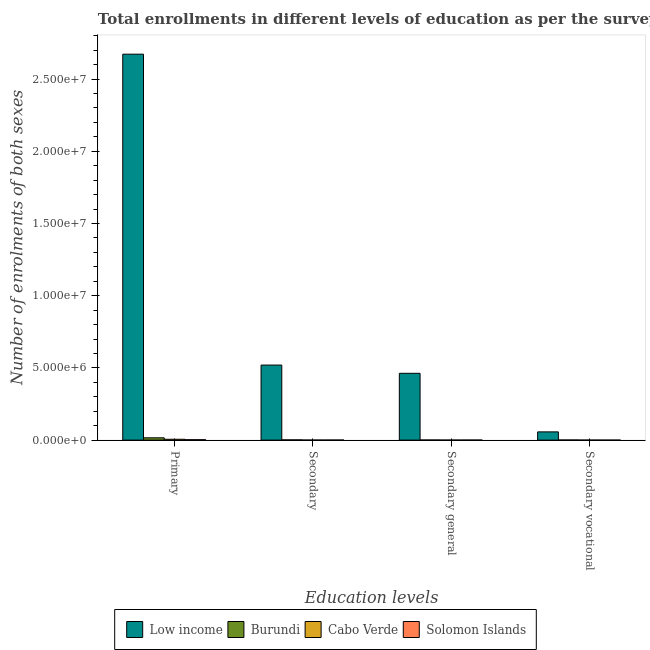Are the number of bars on each tick of the X-axis equal?
Your answer should be compact. Yes. How many bars are there on the 1st tick from the left?
Provide a succinct answer. 4. What is the label of the 3rd group of bars from the left?
Make the answer very short. Secondary general. What is the number of enrolments in primary education in Solomon Islands?
Offer a terse response. 2.89e+04. Across all countries, what is the maximum number of enrolments in secondary general education?
Provide a short and direct response. 4.63e+06. Across all countries, what is the minimum number of enrolments in secondary general education?
Your response must be concise. 2491. In which country was the number of enrolments in secondary general education maximum?
Your answer should be very brief. Low income. In which country was the number of enrolments in primary education minimum?
Provide a short and direct response. Solomon Islands. What is the total number of enrolments in primary education in the graph?
Ensure brevity in your answer.  2.70e+07. What is the difference between the number of enrolments in secondary general education in Burundi and that in Low income?
Offer a terse response. -4.62e+06. What is the difference between the number of enrolments in secondary general education in Solomon Islands and the number of enrolments in primary education in Cabo Verde?
Provide a succinct answer. -5.46e+04. What is the average number of enrolments in secondary education per country?
Your answer should be very brief. 1.30e+06. What is the difference between the number of enrolments in secondary vocational education and number of enrolments in primary education in Cabo Verde?
Ensure brevity in your answer.  -5.75e+04. What is the ratio of the number of enrolments in secondary vocational education in Low income to that in Burundi?
Ensure brevity in your answer.  67.57. Is the number of enrolments in secondary vocational education in Cabo Verde less than that in Burundi?
Offer a very short reply. Yes. Is the difference between the number of enrolments in secondary education in Burundi and Cabo Verde greater than the difference between the number of enrolments in secondary general education in Burundi and Cabo Verde?
Provide a short and direct response. Yes. What is the difference between the highest and the second highest number of enrolments in primary education?
Give a very brief answer. 2.66e+07. What is the difference between the highest and the lowest number of enrolments in secondary general education?
Your answer should be very brief. 4.62e+06. In how many countries, is the number of enrolments in secondary vocational education greater than the average number of enrolments in secondary vocational education taken over all countries?
Your answer should be compact. 1. Is the sum of the number of enrolments in secondary vocational education in Low income and Burundi greater than the maximum number of enrolments in secondary general education across all countries?
Offer a terse response. No. Is it the case that in every country, the sum of the number of enrolments in secondary vocational education and number of enrolments in primary education is greater than the sum of number of enrolments in secondary general education and number of enrolments in secondary education?
Make the answer very short. Yes. What does the 1st bar from the right in Secondary general represents?
Your answer should be compact. Solomon Islands. Is it the case that in every country, the sum of the number of enrolments in primary education and number of enrolments in secondary education is greater than the number of enrolments in secondary general education?
Give a very brief answer. Yes. Are all the bars in the graph horizontal?
Offer a very short reply. No. How many countries are there in the graph?
Ensure brevity in your answer.  4. Are the values on the major ticks of Y-axis written in scientific E-notation?
Make the answer very short. Yes. Does the graph contain any zero values?
Provide a succinct answer. No. Does the graph contain grids?
Provide a succinct answer. No. Where does the legend appear in the graph?
Give a very brief answer. Bottom center. How many legend labels are there?
Offer a terse response. 4. How are the legend labels stacked?
Make the answer very short. Horizontal. What is the title of the graph?
Your answer should be compact. Total enrollments in different levels of education as per the survey of 1980. Does "Cuba" appear as one of the legend labels in the graph?
Ensure brevity in your answer.  No. What is the label or title of the X-axis?
Give a very brief answer. Education levels. What is the label or title of the Y-axis?
Ensure brevity in your answer.  Number of enrolments of both sexes. What is the Number of enrolments of both sexes of Low income in Primary?
Provide a succinct answer. 2.67e+07. What is the Number of enrolments of both sexes in Burundi in Primary?
Make the answer very short. 1.60e+05. What is the Number of enrolments of both sexes of Cabo Verde in Primary?
Offer a terse response. 5.81e+04. What is the Number of enrolments of both sexes of Solomon Islands in Primary?
Offer a terse response. 2.89e+04. What is the Number of enrolments of both sexes in Low income in Secondary?
Your answer should be compact. 5.20e+06. What is the Number of enrolments of both sexes of Burundi in Secondary?
Your answer should be very brief. 1.64e+04. What is the Number of enrolments of both sexes in Cabo Verde in Secondary?
Your response must be concise. 3129. What is the Number of enrolments of both sexes in Solomon Islands in Secondary?
Offer a very short reply. 4030. What is the Number of enrolments of both sexes in Low income in Secondary general?
Ensure brevity in your answer.  4.63e+06. What is the Number of enrolments of both sexes of Burundi in Secondary general?
Your response must be concise. 7967. What is the Number of enrolments of both sexes in Cabo Verde in Secondary general?
Make the answer very short. 2491. What is the Number of enrolments of both sexes of Solomon Islands in Secondary general?
Offer a terse response. 3547. What is the Number of enrolments of both sexes of Low income in Secondary vocational?
Keep it short and to the point. 5.71e+05. What is the Number of enrolments of both sexes of Burundi in Secondary vocational?
Keep it short and to the point. 8443. What is the Number of enrolments of both sexes of Cabo Verde in Secondary vocational?
Offer a very short reply. 638. What is the Number of enrolments of both sexes of Solomon Islands in Secondary vocational?
Offer a very short reply. 483. Across all Education levels, what is the maximum Number of enrolments of both sexes of Low income?
Your answer should be very brief. 2.67e+07. Across all Education levels, what is the maximum Number of enrolments of both sexes of Burundi?
Your response must be concise. 1.60e+05. Across all Education levels, what is the maximum Number of enrolments of both sexes of Cabo Verde?
Offer a very short reply. 5.81e+04. Across all Education levels, what is the maximum Number of enrolments of both sexes in Solomon Islands?
Make the answer very short. 2.89e+04. Across all Education levels, what is the minimum Number of enrolments of both sexes of Low income?
Offer a very short reply. 5.71e+05. Across all Education levels, what is the minimum Number of enrolments of both sexes in Burundi?
Provide a succinct answer. 7967. Across all Education levels, what is the minimum Number of enrolments of both sexes in Cabo Verde?
Make the answer very short. 638. Across all Education levels, what is the minimum Number of enrolments of both sexes of Solomon Islands?
Offer a terse response. 483. What is the total Number of enrolments of both sexes in Low income in the graph?
Make the answer very short. 3.71e+07. What is the total Number of enrolments of both sexes of Burundi in the graph?
Your response must be concise. 1.93e+05. What is the total Number of enrolments of both sexes in Cabo Verde in the graph?
Provide a succinct answer. 6.44e+04. What is the total Number of enrolments of both sexes of Solomon Islands in the graph?
Your response must be concise. 3.69e+04. What is the difference between the Number of enrolments of both sexes in Low income in Primary and that in Secondary?
Provide a succinct answer. 2.15e+07. What is the difference between the Number of enrolments of both sexes of Burundi in Primary and that in Secondary?
Offer a very short reply. 1.43e+05. What is the difference between the Number of enrolments of both sexes in Cabo Verde in Primary and that in Secondary?
Your answer should be very brief. 5.50e+04. What is the difference between the Number of enrolments of both sexes of Solomon Islands in Primary and that in Secondary?
Your response must be concise. 2.48e+04. What is the difference between the Number of enrolments of both sexes in Low income in Primary and that in Secondary general?
Your response must be concise. 2.21e+07. What is the difference between the Number of enrolments of both sexes of Burundi in Primary and that in Secondary general?
Your answer should be compact. 1.52e+05. What is the difference between the Number of enrolments of both sexes in Cabo Verde in Primary and that in Secondary general?
Provide a short and direct response. 5.56e+04. What is the difference between the Number of enrolments of both sexes of Solomon Islands in Primary and that in Secondary general?
Provide a short and direct response. 2.53e+04. What is the difference between the Number of enrolments of both sexes of Low income in Primary and that in Secondary vocational?
Your response must be concise. 2.62e+07. What is the difference between the Number of enrolments of both sexes in Burundi in Primary and that in Secondary vocational?
Provide a short and direct response. 1.51e+05. What is the difference between the Number of enrolments of both sexes of Cabo Verde in Primary and that in Secondary vocational?
Offer a terse response. 5.75e+04. What is the difference between the Number of enrolments of both sexes in Solomon Islands in Primary and that in Secondary vocational?
Offer a very short reply. 2.84e+04. What is the difference between the Number of enrolments of both sexes in Low income in Secondary and that in Secondary general?
Your answer should be very brief. 5.71e+05. What is the difference between the Number of enrolments of both sexes of Burundi in Secondary and that in Secondary general?
Give a very brief answer. 8443. What is the difference between the Number of enrolments of both sexes in Cabo Verde in Secondary and that in Secondary general?
Offer a terse response. 638. What is the difference between the Number of enrolments of both sexes of Solomon Islands in Secondary and that in Secondary general?
Keep it short and to the point. 483. What is the difference between the Number of enrolments of both sexes in Low income in Secondary and that in Secondary vocational?
Offer a terse response. 4.63e+06. What is the difference between the Number of enrolments of both sexes of Burundi in Secondary and that in Secondary vocational?
Your response must be concise. 7967. What is the difference between the Number of enrolments of both sexes in Cabo Verde in Secondary and that in Secondary vocational?
Your response must be concise. 2491. What is the difference between the Number of enrolments of both sexes of Solomon Islands in Secondary and that in Secondary vocational?
Ensure brevity in your answer.  3547. What is the difference between the Number of enrolments of both sexes of Low income in Secondary general and that in Secondary vocational?
Ensure brevity in your answer.  4.05e+06. What is the difference between the Number of enrolments of both sexes of Burundi in Secondary general and that in Secondary vocational?
Provide a short and direct response. -476. What is the difference between the Number of enrolments of both sexes in Cabo Verde in Secondary general and that in Secondary vocational?
Offer a terse response. 1853. What is the difference between the Number of enrolments of both sexes in Solomon Islands in Secondary general and that in Secondary vocational?
Make the answer very short. 3064. What is the difference between the Number of enrolments of both sexes of Low income in Primary and the Number of enrolments of both sexes of Burundi in Secondary?
Ensure brevity in your answer.  2.67e+07. What is the difference between the Number of enrolments of both sexes of Low income in Primary and the Number of enrolments of both sexes of Cabo Verde in Secondary?
Offer a terse response. 2.67e+07. What is the difference between the Number of enrolments of both sexes of Low income in Primary and the Number of enrolments of both sexes of Solomon Islands in Secondary?
Ensure brevity in your answer.  2.67e+07. What is the difference between the Number of enrolments of both sexes in Burundi in Primary and the Number of enrolments of both sexes in Cabo Verde in Secondary?
Keep it short and to the point. 1.57e+05. What is the difference between the Number of enrolments of both sexes in Burundi in Primary and the Number of enrolments of both sexes in Solomon Islands in Secondary?
Ensure brevity in your answer.  1.56e+05. What is the difference between the Number of enrolments of both sexes of Cabo Verde in Primary and the Number of enrolments of both sexes of Solomon Islands in Secondary?
Provide a short and direct response. 5.41e+04. What is the difference between the Number of enrolments of both sexes in Low income in Primary and the Number of enrolments of both sexes in Burundi in Secondary general?
Offer a terse response. 2.67e+07. What is the difference between the Number of enrolments of both sexes in Low income in Primary and the Number of enrolments of both sexes in Cabo Verde in Secondary general?
Provide a short and direct response. 2.67e+07. What is the difference between the Number of enrolments of both sexes of Low income in Primary and the Number of enrolments of both sexes of Solomon Islands in Secondary general?
Your answer should be compact. 2.67e+07. What is the difference between the Number of enrolments of both sexes in Burundi in Primary and the Number of enrolments of both sexes in Cabo Verde in Secondary general?
Your answer should be very brief. 1.57e+05. What is the difference between the Number of enrolments of both sexes of Burundi in Primary and the Number of enrolments of both sexes of Solomon Islands in Secondary general?
Your answer should be very brief. 1.56e+05. What is the difference between the Number of enrolments of both sexes of Cabo Verde in Primary and the Number of enrolments of both sexes of Solomon Islands in Secondary general?
Provide a succinct answer. 5.46e+04. What is the difference between the Number of enrolments of both sexes in Low income in Primary and the Number of enrolments of both sexes in Burundi in Secondary vocational?
Make the answer very short. 2.67e+07. What is the difference between the Number of enrolments of both sexes of Low income in Primary and the Number of enrolments of both sexes of Cabo Verde in Secondary vocational?
Offer a very short reply. 2.67e+07. What is the difference between the Number of enrolments of both sexes of Low income in Primary and the Number of enrolments of both sexes of Solomon Islands in Secondary vocational?
Make the answer very short. 2.67e+07. What is the difference between the Number of enrolments of both sexes in Burundi in Primary and the Number of enrolments of both sexes in Cabo Verde in Secondary vocational?
Your response must be concise. 1.59e+05. What is the difference between the Number of enrolments of both sexes of Burundi in Primary and the Number of enrolments of both sexes of Solomon Islands in Secondary vocational?
Offer a terse response. 1.59e+05. What is the difference between the Number of enrolments of both sexes in Cabo Verde in Primary and the Number of enrolments of both sexes in Solomon Islands in Secondary vocational?
Ensure brevity in your answer.  5.76e+04. What is the difference between the Number of enrolments of both sexes in Low income in Secondary and the Number of enrolments of both sexes in Burundi in Secondary general?
Keep it short and to the point. 5.19e+06. What is the difference between the Number of enrolments of both sexes in Low income in Secondary and the Number of enrolments of both sexes in Cabo Verde in Secondary general?
Make the answer very short. 5.19e+06. What is the difference between the Number of enrolments of both sexes of Low income in Secondary and the Number of enrolments of both sexes of Solomon Islands in Secondary general?
Your answer should be very brief. 5.19e+06. What is the difference between the Number of enrolments of both sexes of Burundi in Secondary and the Number of enrolments of both sexes of Cabo Verde in Secondary general?
Make the answer very short. 1.39e+04. What is the difference between the Number of enrolments of both sexes of Burundi in Secondary and the Number of enrolments of both sexes of Solomon Islands in Secondary general?
Keep it short and to the point. 1.29e+04. What is the difference between the Number of enrolments of both sexes of Cabo Verde in Secondary and the Number of enrolments of both sexes of Solomon Islands in Secondary general?
Your answer should be compact. -418. What is the difference between the Number of enrolments of both sexes in Low income in Secondary and the Number of enrolments of both sexes in Burundi in Secondary vocational?
Your answer should be compact. 5.19e+06. What is the difference between the Number of enrolments of both sexes in Low income in Secondary and the Number of enrolments of both sexes in Cabo Verde in Secondary vocational?
Offer a very short reply. 5.20e+06. What is the difference between the Number of enrolments of both sexes of Low income in Secondary and the Number of enrolments of both sexes of Solomon Islands in Secondary vocational?
Give a very brief answer. 5.20e+06. What is the difference between the Number of enrolments of both sexes in Burundi in Secondary and the Number of enrolments of both sexes in Cabo Verde in Secondary vocational?
Your response must be concise. 1.58e+04. What is the difference between the Number of enrolments of both sexes of Burundi in Secondary and the Number of enrolments of both sexes of Solomon Islands in Secondary vocational?
Ensure brevity in your answer.  1.59e+04. What is the difference between the Number of enrolments of both sexes in Cabo Verde in Secondary and the Number of enrolments of both sexes in Solomon Islands in Secondary vocational?
Your response must be concise. 2646. What is the difference between the Number of enrolments of both sexes in Low income in Secondary general and the Number of enrolments of both sexes in Burundi in Secondary vocational?
Your answer should be very brief. 4.62e+06. What is the difference between the Number of enrolments of both sexes in Low income in Secondary general and the Number of enrolments of both sexes in Cabo Verde in Secondary vocational?
Your answer should be compact. 4.62e+06. What is the difference between the Number of enrolments of both sexes in Low income in Secondary general and the Number of enrolments of both sexes in Solomon Islands in Secondary vocational?
Your response must be concise. 4.62e+06. What is the difference between the Number of enrolments of both sexes of Burundi in Secondary general and the Number of enrolments of both sexes of Cabo Verde in Secondary vocational?
Ensure brevity in your answer.  7329. What is the difference between the Number of enrolments of both sexes of Burundi in Secondary general and the Number of enrolments of both sexes of Solomon Islands in Secondary vocational?
Give a very brief answer. 7484. What is the difference between the Number of enrolments of both sexes of Cabo Verde in Secondary general and the Number of enrolments of both sexes of Solomon Islands in Secondary vocational?
Offer a terse response. 2008. What is the average Number of enrolments of both sexes of Low income per Education levels?
Offer a very short reply. 9.28e+06. What is the average Number of enrolments of both sexes of Burundi per Education levels?
Give a very brief answer. 4.81e+04. What is the average Number of enrolments of both sexes of Cabo Verde per Education levels?
Your response must be concise. 1.61e+04. What is the average Number of enrolments of both sexes in Solomon Islands per Education levels?
Your answer should be very brief. 9232.5. What is the difference between the Number of enrolments of both sexes in Low income and Number of enrolments of both sexes in Burundi in Primary?
Offer a terse response. 2.66e+07. What is the difference between the Number of enrolments of both sexes of Low income and Number of enrolments of both sexes of Cabo Verde in Primary?
Provide a succinct answer. 2.67e+07. What is the difference between the Number of enrolments of both sexes in Low income and Number of enrolments of both sexes in Solomon Islands in Primary?
Offer a terse response. 2.67e+07. What is the difference between the Number of enrolments of both sexes of Burundi and Number of enrolments of both sexes of Cabo Verde in Primary?
Your response must be concise. 1.02e+05. What is the difference between the Number of enrolments of both sexes of Burundi and Number of enrolments of both sexes of Solomon Islands in Primary?
Ensure brevity in your answer.  1.31e+05. What is the difference between the Number of enrolments of both sexes in Cabo Verde and Number of enrolments of both sexes in Solomon Islands in Primary?
Provide a succinct answer. 2.92e+04. What is the difference between the Number of enrolments of both sexes in Low income and Number of enrolments of both sexes in Burundi in Secondary?
Give a very brief answer. 5.18e+06. What is the difference between the Number of enrolments of both sexes in Low income and Number of enrolments of both sexes in Cabo Verde in Secondary?
Make the answer very short. 5.19e+06. What is the difference between the Number of enrolments of both sexes of Low income and Number of enrolments of both sexes of Solomon Islands in Secondary?
Your answer should be compact. 5.19e+06. What is the difference between the Number of enrolments of both sexes of Burundi and Number of enrolments of both sexes of Cabo Verde in Secondary?
Offer a very short reply. 1.33e+04. What is the difference between the Number of enrolments of both sexes in Burundi and Number of enrolments of both sexes in Solomon Islands in Secondary?
Provide a succinct answer. 1.24e+04. What is the difference between the Number of enrolments of both sexes of Cabo Verde and Number of enrolments of both sexes of Solomon Islands in Secondary?
Your answer should be compact. -901. What is the difference between the Number of enrolments of both sexes of Low income and Number of enrolments of both sexes of Burundi in Secondary general?
Your response must be concise. 4.62e+06. What is the difference between the Number of enrolments of both sexes in Low income and Number of enrolments of both sexes in Cabo Verde in Secondary general?
Your answer should be very brief. 4.62e+06. What is the difference between the Number of enrolments of both sexes in Low income and Number of enrolments of both sexes in Solomon Islands in Secondary general?
Keep it short and to the point. 4.62e+06. What is the difference between the Number of enrolments of both sexes in Burundi and Number of enrolments of both sexes in Cabo Verde in Secondary general?
Your answer should be very brief. 5476. What is the difference between the Number of enrolments of both sexes of Burundi and Number of enrolments of both sexes of Solomon Islands in Secondary general?
Your response must be concise. 4420. What is the difference between the Number of enrolments of both sexes in Cabo Verde and Number of enrolments of both sexes in Solomon Islands in Secondary general?
Offer a terse response. -1056. What is the difference between the Number of enrolments of both sexes in Low income and Number of enrolments of both sexes in Burundi in Secondary vocational?
Ensure brevity in your answer.  5.62e+05. What is the difference between the Number of enrolments of both sexes of Low income and Number of enrolments of both sexes of Cabo Verde in Secondary vocational?
Offer a very short reply. 5.70e+05. What is the difference between the Number of enrolments of both sexes in Low income and Number of enrolments of both sexes in Solomon Islands in Secondary vocational?
Your answer should be compact. 5.70e+05. What is the difference between the Number of enrolments of both sexes of Burundi and Number of enrolments of both sexes of Cabo Verde in Secondary vocational?
Provide a short and direct response. 7805. What is the difference between the Number of enrolments of both sexes in Burundi and Number of enrolments of both sexes in Solomon Islands in Secondary vocational?
Offer a terse response. 7960. What is the difference between the Number of enrolments of both sexes of Cabo Verde and Number of enrolments of both sexes of Solomon Islands in Secondary vocational?
Your answer should be compact. 155. What is the ratio of the Number of enrolments of both sexes in Low income in Primary to that in Secondary?
Provide a succinct answer. 5.14. What is the ratio of the Number of enrolments of both sexes of Burundi in Primary to that in Secondary?
Offer a terse response. 9.73. What is the ratio of the Number of enrolments of both sexes of Cabo Verde in Primary to that in Secondary?
Your response must be concise. 18.57. What is the ratio of the Number of enrolments of both sexes of Solomon Islands in Primary to that in Secondary?
Make the answer very short. 7.16. What is the ratio of the Number of enrolments of both sexes of Low income in Primary to that in Secondary general?
Offer a terse response. 5.78. What is the ratio of the Number of enrolments of both sexes of Burundi in Primary to that in Secondary general?
Offer a very short reply. 20.05. What is the ratio of the Number of enrolments of both sexes of Cabo Verde in Primary to that in Secondary general?
Provide a short and direct response. 23.33. What is the ratio of the Number of enrolments of both sexes of Solomon Islands in Primary to that in Secondary general?
Your response must be concise. 8.14. What is the ratio of the Number of enrolments of both sexes of Low income in Primary to that in Secondary vocational?
Your answer should be very brief. 46.84. What is the ratio of the Number of enrolments of both sexes of Burundi in Primary to that in Secondary vocational?
Keep it short and to the point. 18.92. What is the ratio of the Number of enrolments of both sexes of Cabo Verde in Primary to that in Secondary vocational?
Your answer should be very brief. 91.08. What is the ratio of the Number of enrolments of both sexes of Solomon Islands in Primary to that in Secondary vocational?
Your response must be concise. 59.77. What is the ratio of the Number of enrolments of both sexes in Low income in Secondary to that in Secondary general?
Make the answer very short. 1.12. What is the ratio of the Number of enrolments of both sexes of Burundi in Secondary to that in Secondary general?
Your response must be concise. 2.06. What is the ratio of the Number of enrolments of both sexes in Cabo Verde in Secondary to that in Secondary general?
Provide a succinct answer. 1.26. What is the ratio of the Number of enrolments of both sexes in Solomon Islands in Secondary to that in Secondary general?
Provide a short and direct response. 1.14. What is the ratio of the Number of enrolments of both sexes of Low income in Secondary to that in Secondary vocational?
Give a very brief answer. 9.11. What is the ratio of the Number of enrolments of both sexes of Burundi in Secondary to that in Secondary vocational?
Your answer should be compact. 1.94. What is the ratio of the Number of enrolments of both sexes of Cabo Verde in Secondary to that in Secondary vocational?
Give a very brief answer. 4.9. What is the ratio of the Number of enrolments of both sexes of Solomon Islands in Secondary to that in Secondary vocational?
Make the answer very short. 8.34. What is the ratio of the Number of enrolments of both sexes in Low income in Secondary general to that in Secondary vocational?
Offer a very short reply. 8.11. What is the ratio of the Number of enrolments of both sexes of Burundi in Secondary general to that in Secondary vocational?
Your response must be concise. 0.94. What is the ratio of the Number of enrolments of both sexes in Cabo Verde in Secondary general to that in Secondary vocational?
Provide a succinct answer. 3.9. What is the ratio of the Number of enrolments of both sexes in Solomon Islands in Secondary general to that in Secondary vocational?
Provide a succinct answer. 7.34. What is the difference between the highest and the second highest Number of enrolments of both sexes in Low income?
Offer a terse response. 2.15e+07. What is the difference between the highest and the second highest Number of enrolments of both sexes in Burundi?
Keep it short and to the point. 1.43e+05. What is the difference between the highest and the second highest Number of enrolments of both sexes in Cabo Verde?
Your answer should be very brief. 5.50e+04. What is the difference between the highest and the second highest Number of enrolments of both sexes of Solomon Islands?
Ensure brevity in your answer.  2.48e+04. What is the difference between the highest and the lowest Number of enrolments of both sexes of Low income?
Give a very brief answer. 2.62e+07. What is the difference between the highest and the lowest Number of enrolments of both sexes in Burundi?
Give a very brief answer. 1.52e+05. What is the difference between the highest and the lowest Number of enrolments of both sexes in Cabo Verde?
Offer a very short reply. 5.75e+04. What is the difference between the highest and the lowest Number of enrolments of both sexes in Solomon Islands?
Keep it short and to the point. 2.84e+04. 